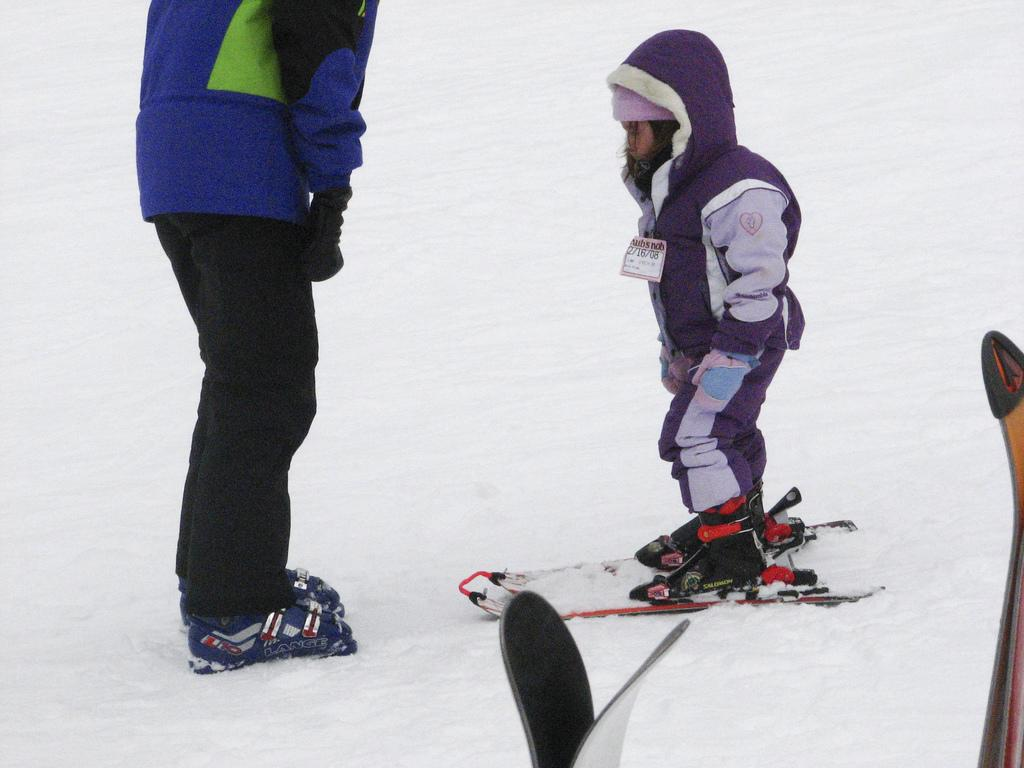What is the main activity being depicted in the image? There is a person standing on ski boards in the image, suggesting that skiing is the main activity. Are there any other people in the image? Yes, there is another person standing in the image. What equipment is visible in the foreground of the image? Ski boards are present in the foreground of the image. What type of terrain is visible at the bottom of the image? There is snow at the bottom of the image. What type of train can be seen in the image? There is no train present in the image; it features a person on ski boards and another person standing nearby. What is the minister doing in the image? There is no minister present in the image, and therefore no activity involving a minister can be observed. 